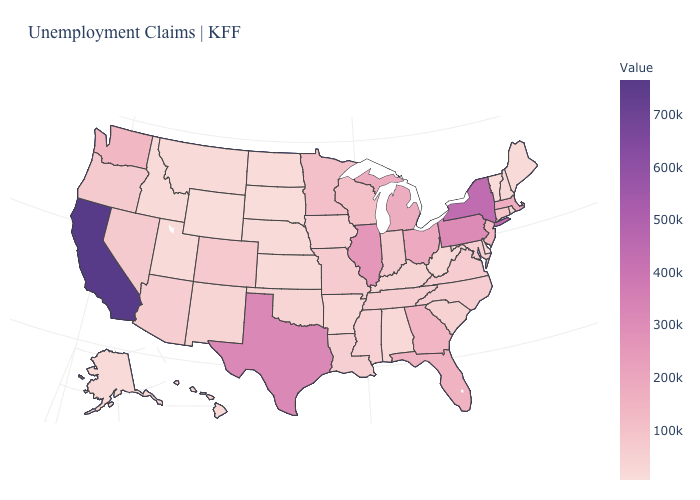Which states have the highest value in the USA?
Quick response, please. California. Does Alabama have a lower value than Michigan?
Short answer required. Yes. Which states have the lowest value in the USA?
Concise answer only. Wyoming. Which states have the lowest value in the USA?
Be succinct. Wyoming. 